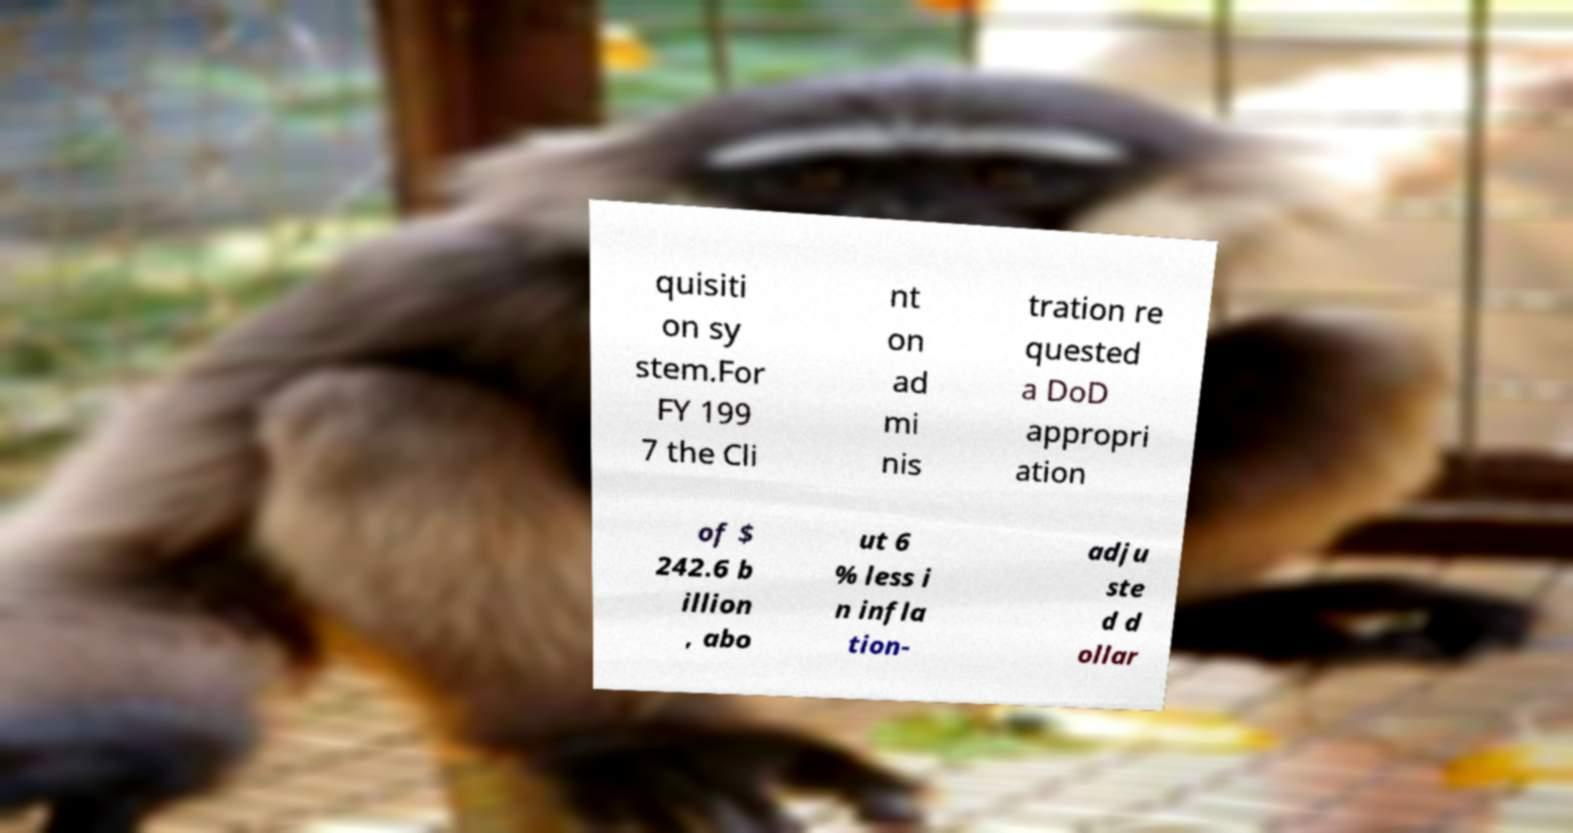For documentation purposes, I need the text within this image transcribed. Could you provide that? quisiti on sy stem.For FY 199 7 the Cli nt on ad mi nis tration re quested a DoD appropri ation of $ 242.6 b illion , abo ut 6 % less i n infla tion- adju ste d d ollar 